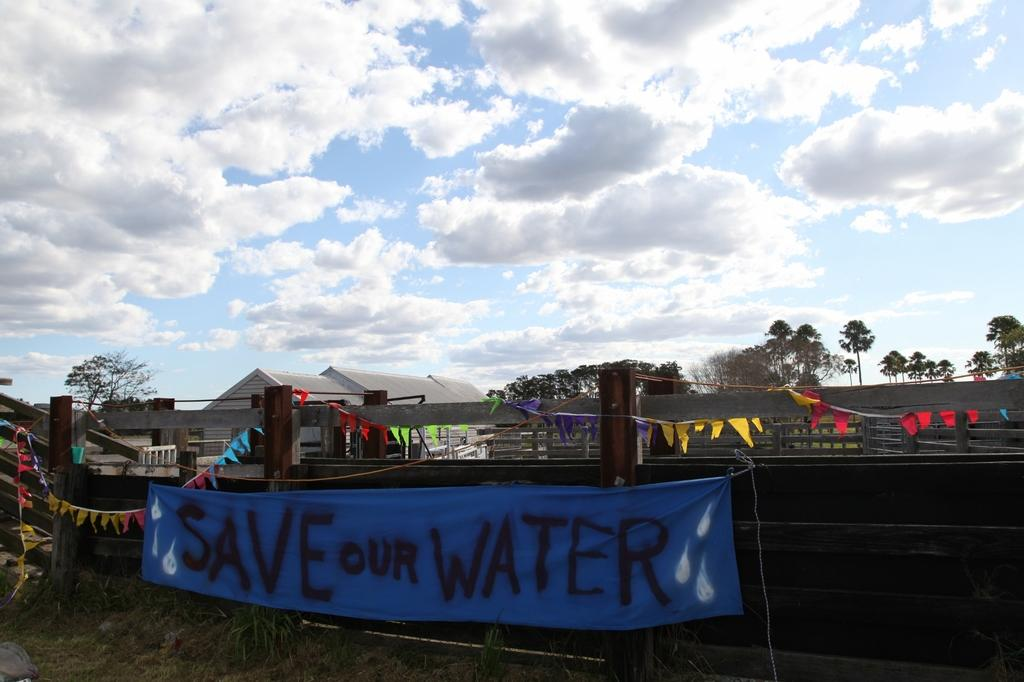What type of natural elements can be seen in the image? There are trees in the image. What man-made structures are present in the image? There are fences and a house in the image. What decorative elements can be seen hanging in the image? Decorative papers are attached to a rope in the image. What type of text can be seen in the image? There is a cloth with some text in the image. What is visible in the sky in the image? There are clouds in the sky in the image. What type of nail is being used to hold the argument in the image? There is no nail or argument present in the image. How does the slip affect the decorative papers in the image? There is no slip present in the image, and therefore it cannot affect the decorative papers. 